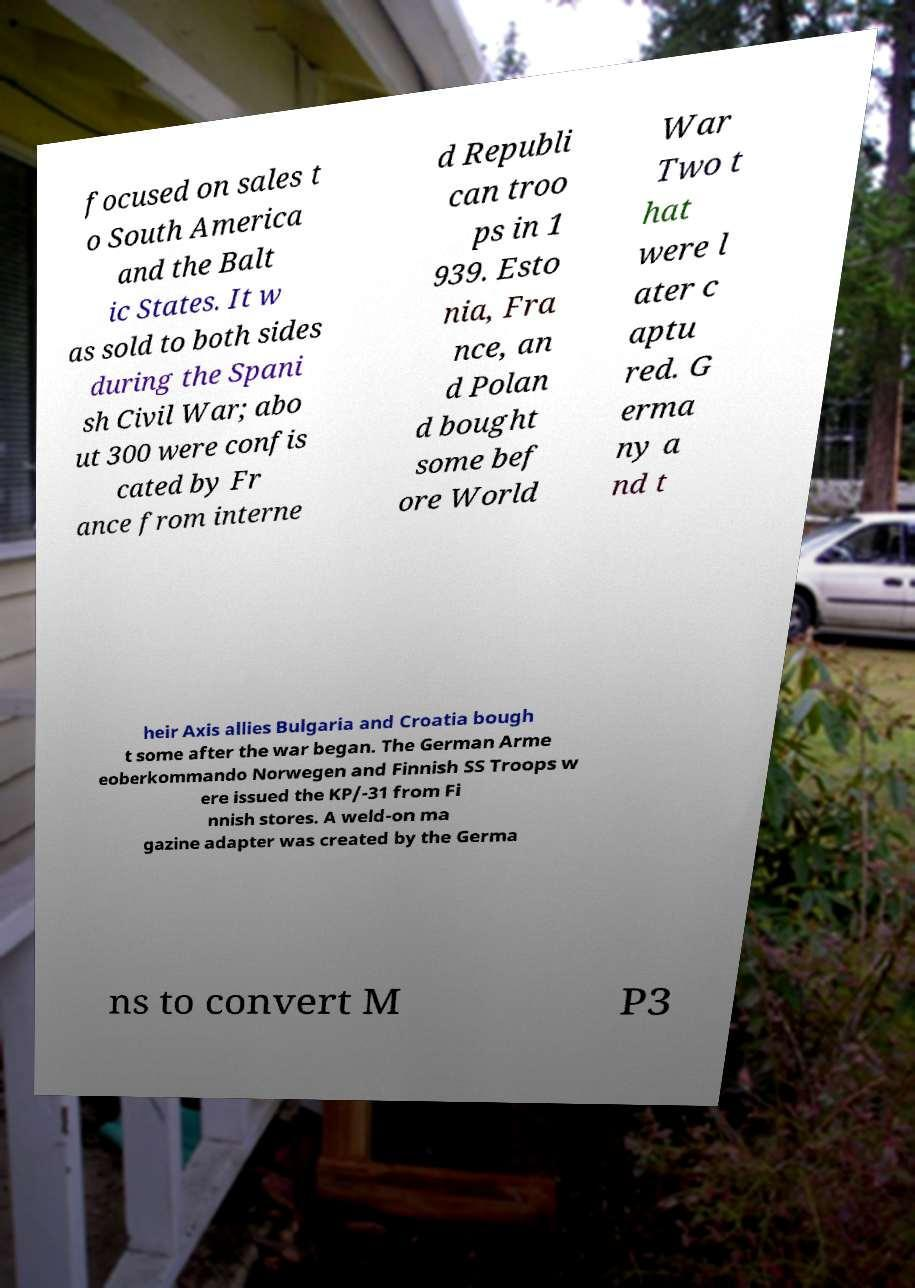Can you read and provide the text displayed in the image?This photo seems to have some interesting text. Can you extract and type it out for me? focused on sales t o South America and the Balt ic States. It w as sold to both sides during the Spani sh Civil War; abo ut 300 were confis cated by Fr ance from interne d Republi can troo ps in 1 939. Esto nia, Fra nce, an d Polan d bought some bef ore World War Two t hat were l ater c aptu red. G erma ny a nd t heir Axis allies Bulgaria and Croatia bough t some after the war began. The German Arme eoberkommando Norwegen and Finnish SS Troops w ere issued the KP/-31 from Fi nnish stores. A weld-on ma gazine adapter was created by the Germa ns to convert M P3 